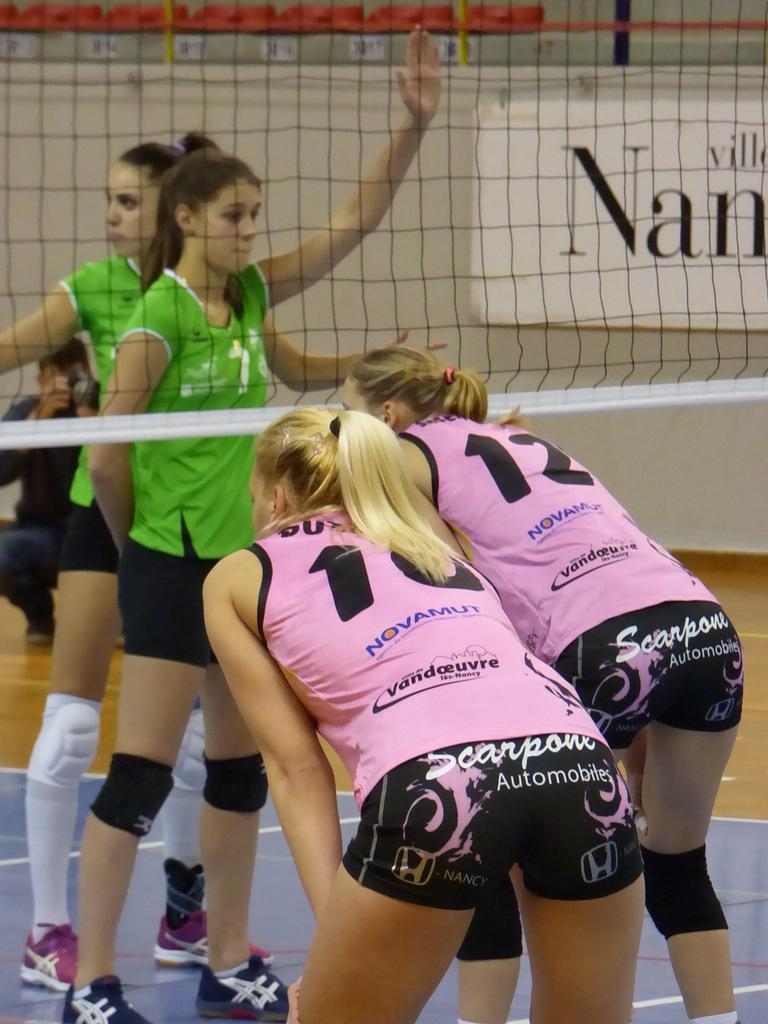<image>
Give a short and clear explanation of the subsequent image. Scarpone Automobiles reads the sponsor on these volleyball player's uniforms. 